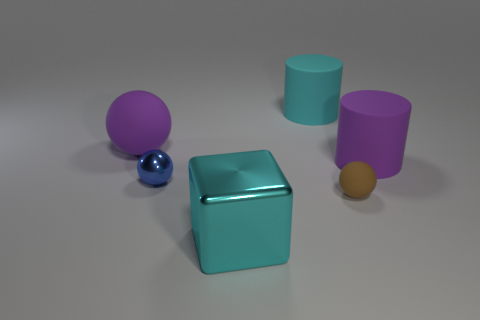Add 4 small blue metal spheres. How many objects exist? 10 Subtract all cylinders. How many objects are left? 4 Add 1 purple rubber spheres. How many purple rubber spheres are left? 2 Add 4 big purple rubber balls. How many big purple rubber balls exist? 5 Subtract 0 green blocks. How many objects are left? 6 Subtract all green balls. Subtract all shiny blocks. How many objects are left? 5 